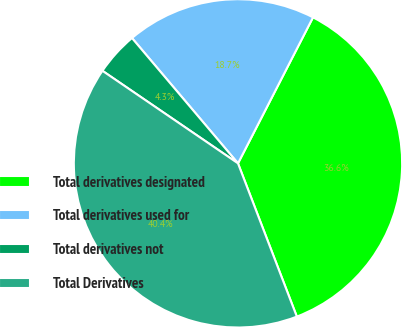<chart> <loc_0><loc_0><loc_500><loc_500><pie_chart><fcel>Total derivatives designated<fcel>Total derivatives used for<fcel>Total derivatives not<fcel>Total Derivatives<nl><fcel>36.61%<fcel>18.73%<fcel>4.29%<fcel>40.37%<nl></chart> 